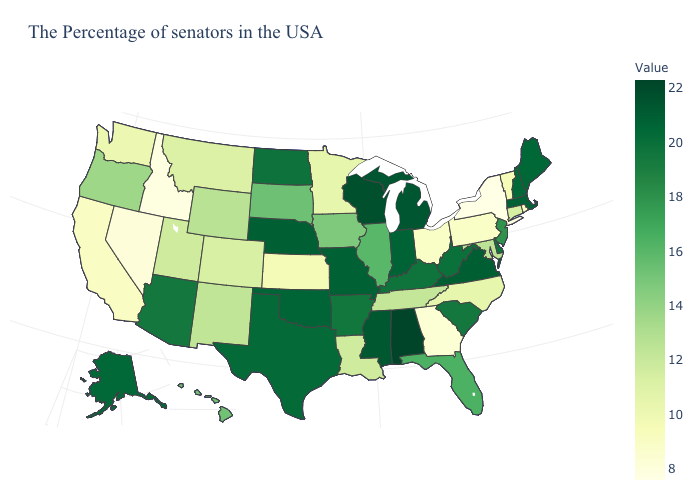Among the states that border Texas , does Oklahoma have the highest value?
Concise answer only. Yes. Does Nebraska have the lowest value in the MidWest?
Quick response, please. No. Does New York have the lowest value in the USA?
Quick response, please. Yes. Does Tennessee have a lower value than Hawaii?
Answer briefly. Yes. 